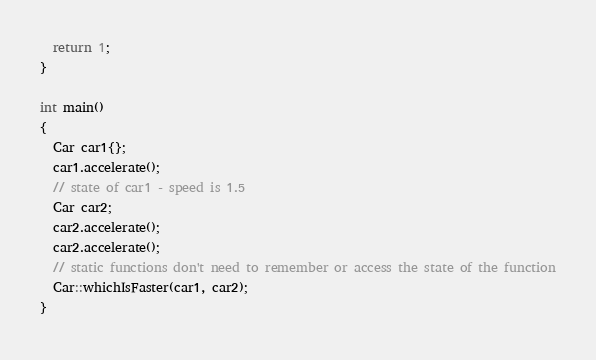<code> <loc_0><loc_0><loc_500><loc_500><_C++_>  return 1;
}

int main()
{
  Car car1{};
  car1.accelerate();
  // state of car1 - speed is 1.5
  Car car2;
  car2.accelerate();
  car2.accelerate();
  // static functions don't need to remember or access the state of the function
  Car::whichIsFaster(car1, car2);
}</code> 